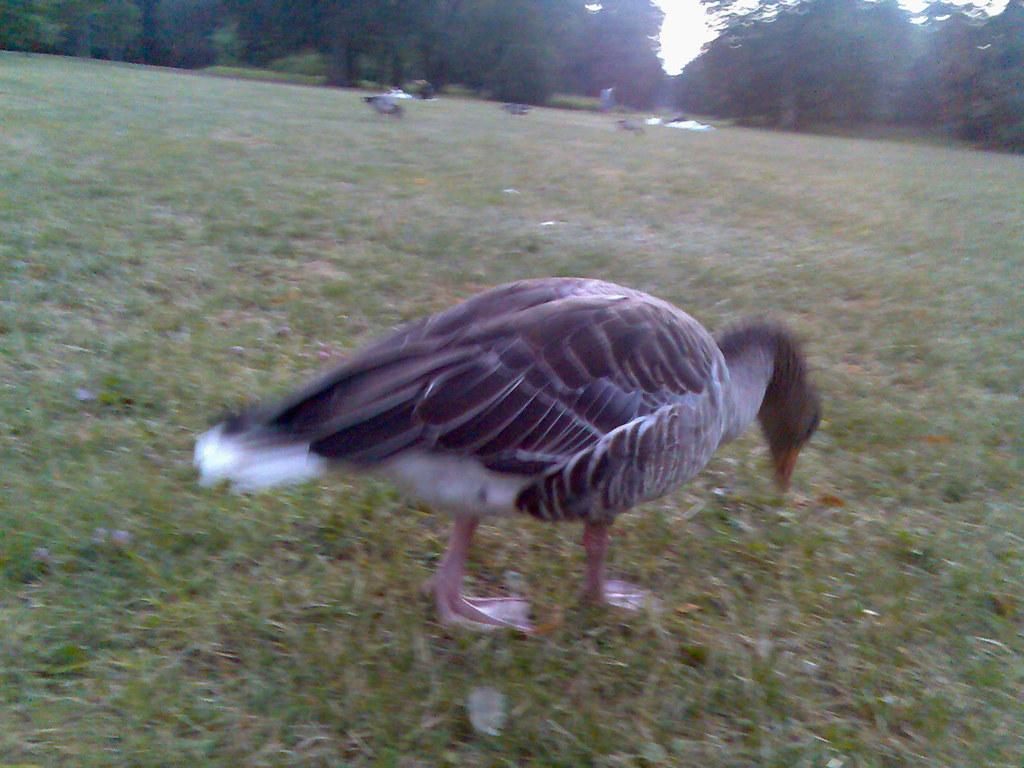What type of animal is present in the image? There is a bird in the image. Where is the bird located? The bird is on grassy land. What can be seen in the background of the image? There are trees in the background of the image. What flavor of ice cream is the bird holding in the image? There is no ice cream present in the image, and the bird is not holding anything. 